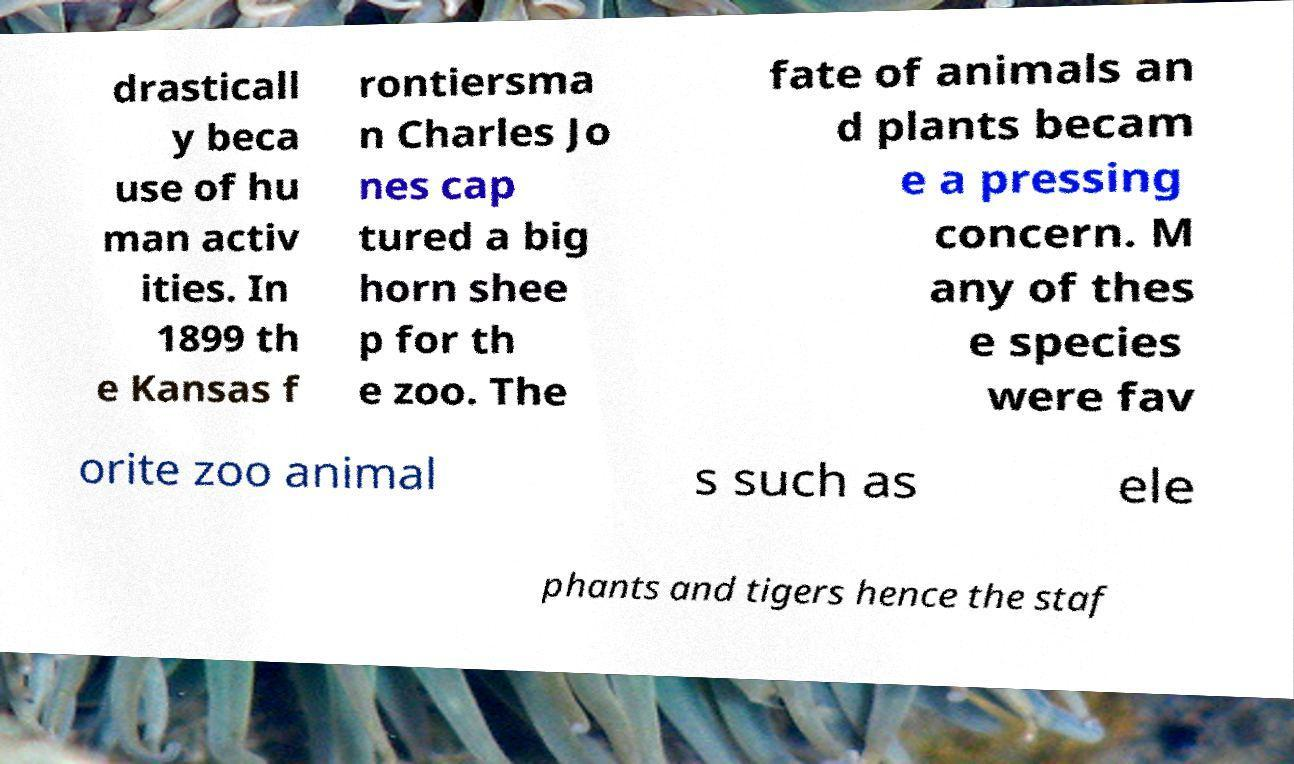Can you read and provide the text displayed in the image?This photo seems to have some interesting text. Can you extract and type it out for me? drasticall y beca use of hu man activ ities. In 1899 th e Kansas f rontiersma n Charles Jo nes cap tured a big horn shee p for th e zoo. The fate of animals an d plants becam e a pressing concern. M any of thes e species were fav orite zoo animal s such as ele phants and tigers hence the staf 